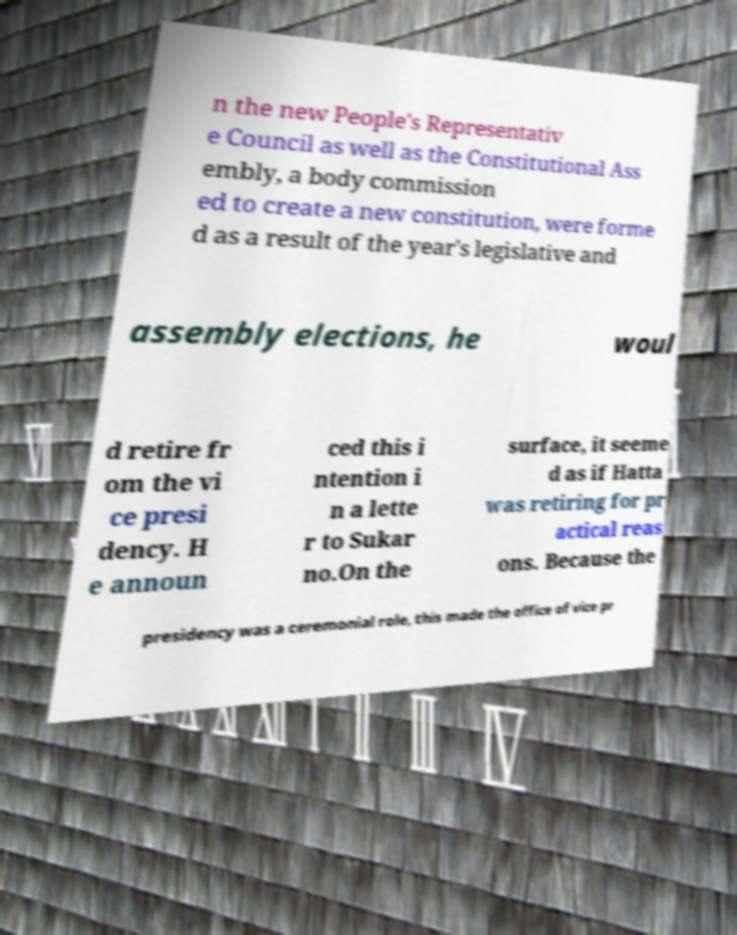Can you read and provide the text displayed in the image?This photo seems to have some interesting text. Can you extract and type it out for me? n the new People's Representativ e Council as well as the Constitutional Ass embly, a body commission ed to create a new constitution, were forme d as a result of the year's legislative and assembly elections, he woul d retire fr om the vi ce presi dency. H e announ ced this i ntention i n a lette r to Sukar no.On the surface, it seeme d as if Hatta was retiring for pr actical reas ons. Because the presidency was a ceremonial role, this made the office of vice pr 